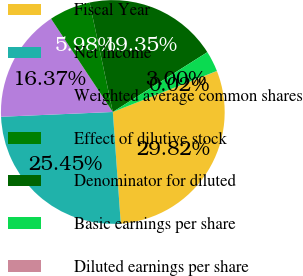Convert chart to OTSL. <chart><loc_0><loc_0><loc_500><loc_500><pie_chart><fcel>Fiscal Year<fcel>Net income<fcel>Weighted average common shares<fcel>Effect of dilutive stock<fcel>Denominator for diluted<fcel>Basic earnings per share<fcel>Diluted earnings per share<nl><fcel>29.82%<fcel>25.45%<fcel>16.37%<fcel>5.98%<fcel>19.35%<fcel>3.0%<fcel>0.02%<nl></chart> 